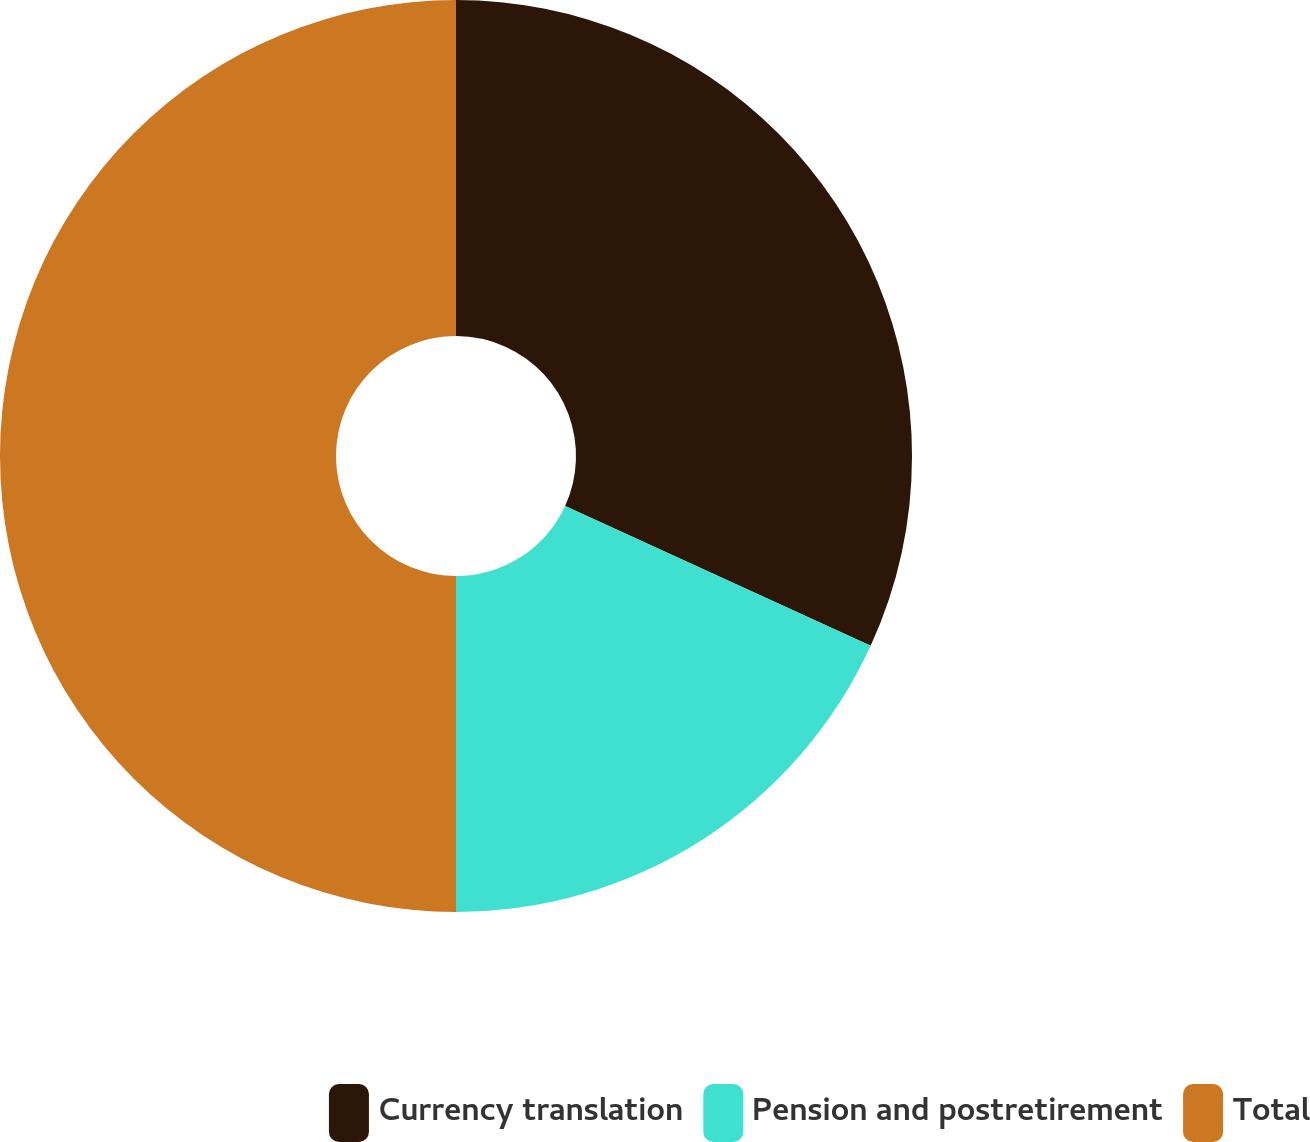Convert chart. <chart><loc_0><loc_0><loc_500><loc_500><pie_chart><fcel>Currency translation<fcel>Pension and postretirement<fcel>Total<nl><fcel>31.83%<fcel>18.17%<fcel>50.0%<nl></chart> 